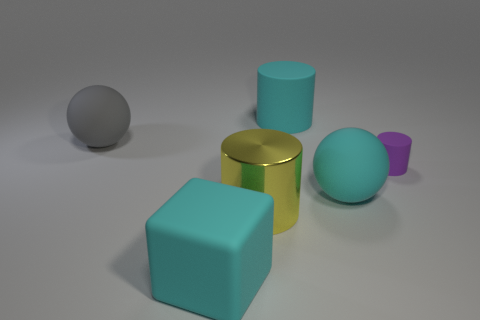How many other yellow shiny things are the same shape as the large yellow thing?
Provide a succinct answer. 0. There is a large sphere on the right side of the metallic cylinder; what is its material?
Your answer should be compact. Rubber. There is a big object right of the big cyan cylinder; is it the same shape as the yellow thing?
Keep it short and to the point. No. Are there any yellow balls that have the same size as the cube?
Ensure brevity in your answer.  No. Is the shape of the large metal thing the same as the big cyan matte thing behind the tiny purple thing?
Provide a short and direct response. Yes. Are there fewer metallic things that are behind the large yellow cylinder than rubber cylinders?
Make the answer very short. Yes. Is the shape of the yellow object the same as the small purple matte thing?
Ensure brevity in your answer.  Yes. There is a purple object that is made of the same material as the block; what size is it?
Give a very brief answer. Small. Are there fewer big cyan matte balls than big red rubber blocks?
Offer a terse response. No. What number of big things are cyan things or cyan cylinders?
Offer a very short reply. 3. 